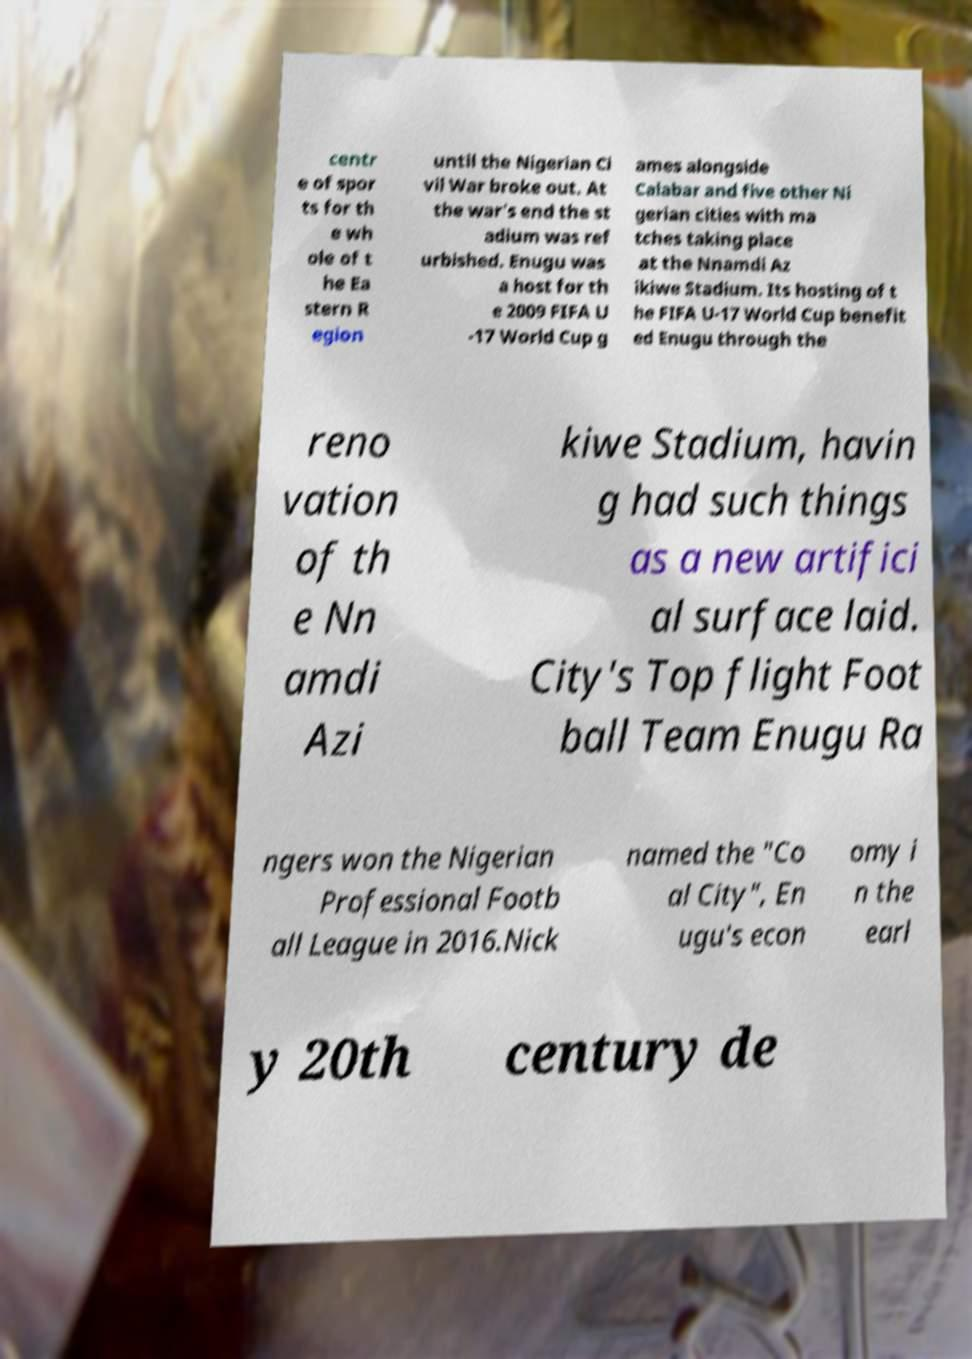Could you assist in decoding the text presented in this image and type it out clearly? centr e of spor ts for th e wh ole of t he Ea stern R egion until the Nigerian Ci vil War broke out. At the war's end the st adium was ref urbished. Enugu was a host for th e 2009 FIFA U -17 World Cup g ames alongside Calabar and five other Ni gerian cities with ma tches taking place at the Nnamdi Az ikiwe Stadium. Its hosting of t he FIFA U-17 World Cup benefit ed Enugu through the reno vation of th e Nn amdi Azi kiwe Stadium, havin g had such things as a new artifici al surface laid. City's Top flight Foot ball Team Enugu Ra ngers won the Nigerian Professional Footb all League in 2016.Nick named the "Co al City", En ugu's econ omy i n the earl y 20th century de 